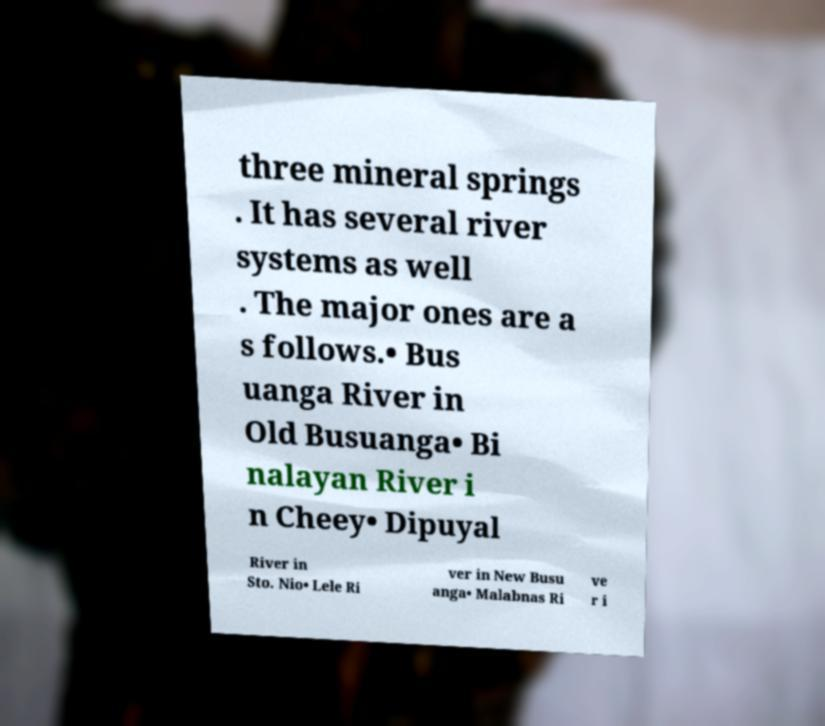I need the written content from this picture converted into text. Can you do that? three mineral springs . It has several river systems as well . The major ones are a s follows.• Bus uanga River in Old Busuanga• Bi nalayan River i n Cheey• Dipuyal River in Sto. Nio• Lele Ri ver in New Busu anga• Malabnas Ri ve r i 